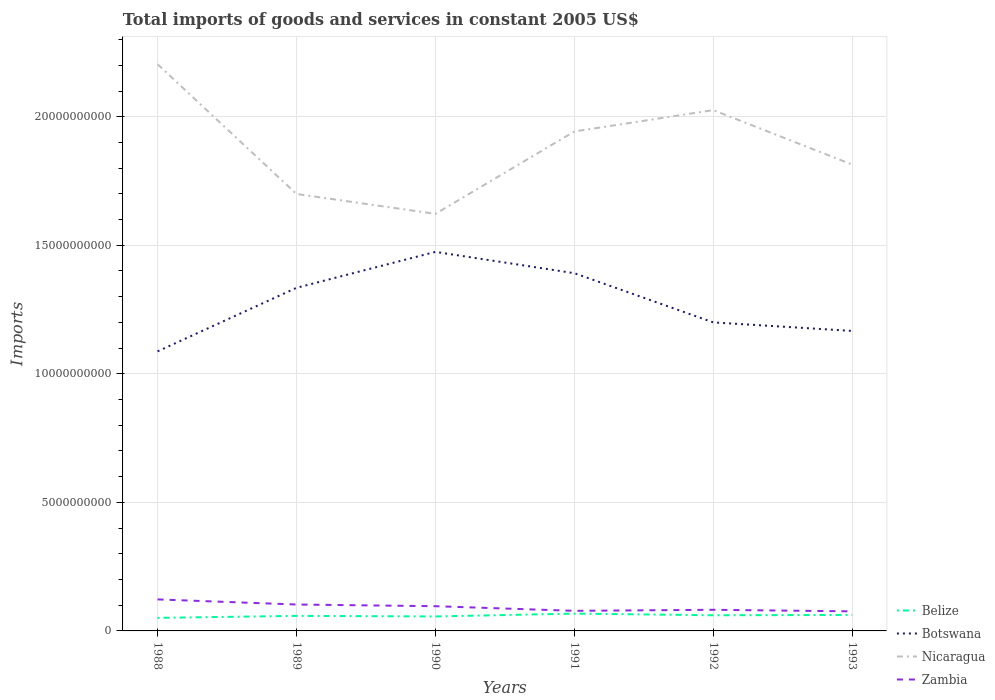How many different coloured lines are there?
Offer a terse response. 4. Is the number of lines equal to the number of legend labels?
Your answer should be compact. Yes. Across all years, what is the maximum total imports of goods and services in Zambia?
Offer a terse response. 7.61e+08. What is the total total imports of goods and services in Nicaragua in the graph?
Keep it short and to the point. 1.78e+09. What is the difference between the highest and the second highest total imports of goods and services in Botswana?
Give a very brief answer. 3.87e+09. What is the difference between two consecutive major ticks on the Y-axis?
Your answer should be very brief. 5.00e+09. Does the graph contain any zero values?
Your response must be concise. No. Does the graph contain grids?
Provide a succinct answer. Yes. Where does the legend appear in the graph?
Give a very brief answer. Bottom right. How many legend labels are there?
Provide a succinct answer. 4. What is the title of the graph?
Ensure brevity in your answer.  Total imports of goods and services in constant 2005 US$. Does "Gabon" appear as one of the legend labels in the graph?
Your response must be concise. No. What is the label or title of the X-axis?
Your answer should be compact. Years. What is the label or title of the Y-axis?
Offer a very short reply. Imports. What is the Imports in Belize in 1988?
Your answer should be compact. 5.08e+08. What is the Imports of Botswana in 1988?
Offer a very short reply. 1.09e+1. What is the Imports in Nicaragua in 1988?
Make the answer very short. 2.20e+1. What is the Imports in Zambia in 1988?
Give a very brief answer. 1.23e+09. What is the Imports in Belize in 1989?
Your answer should be compact. 5.85e+08. What is the Imports in Botswana in 1989?
Your response must be concise. 1.33e+1. What is the Imports of Nicaragua in 1989?
Ensure brevity in your answer.  1.70e+1. What is the Imports of Zambia in 1989?
Give a very brief answer. 1.03e+09. What is the Imports of Belize in 1990?
Offer a terse response. 5.63e+08. What is the Imports of Botswana in 1990?
Give a very brief answer. 1.47e+1. What is the Imports in Nicaragua in 1990?
Make the answer very short. 1.62e+1. What is the Imports of Zambia in 1990?
Your response must be concise. 9.62e+08. What is the Imports of Belize in 1991?
Keep it short and to the point. 6.74e+08. What is the Imports of Botswana in 1991?
Your answer should be very brief. 1.39e+1. What is the Imports of Nicaragua in 1991?
Your answer should be very brief. 1.94e+1. What is the Imports in Zambia in 1991?
Keep it short and to the point. 7.81e+08. What is the Imports in Belize in 1992?
Provide a succinct answer. 6.09e+08. What is the Imports of Botswana in 1992?
Give a very brief answer. 1.20e+1. What is the Imports in Nicaragua in 1992?
Ensure brevity in your answer.  2.03e+1. What is the Imports in Zambia in 1992?
Provide a succinct answer. 8.22e+08. What is the Imports in Belize in 1993?
Ensure brevity in your answer.  6.22e+08. What is the Imports of Botswana in 1993?
Offer a terse response. 1.17e+1. What is the Imports of Nicaragua in 1993?
Offer a terse response. 1.81e+1. What is the Imports in Zambia in 1993?
Offer a terse response. 7.61e+08. Across all years, what is the maximum Imports of Belize?
Offer a terse response. 6.74e+08. Across all years, what is the maximum Imports of Botswana?
Offer a terse response. 1.47e+1. Across all years, what is the maximum Imports in Nicaragua?
Give a very brief answer. 2.20e+1. Across all years, what is the maximum Imports of Zambia?
Give a very brief answer. 1.23e+09. Across all years, what is the minimum Imports of Belize?
Keep it short and to the point. 5.08e+08. Across all years, what is the minimum Imports of Botswana?
Provide a short and direct response. 1.09e+1. Across all years, what is the minimum Imports in Nicaragua?
Make the answer very short. 1.62e+1. Across all years, what is the minimum Imports of Zambia?
Give a very brief answer. 7.61e+08. What is the total Imports in Belize in the graph?
Your response must be concise. 3.56e+09. What is the total Imports in Botswana in the graph?
Keep it short and to the point. 7.65e+1. What is the total Imports in Nicaragua in the graph?
Provide a short and direct response. 1.13e+11. What is the total Imports in Zambia in the graph?
Keep it short and to the point. 5.58e+09. What is the difference between the Imports of Belize in 1988 and that in 1989?
Provide a succinct answer. -7.74e+07. What is the difference between the Imports of Botswana in 1988 and that in 1989?
Ensure brevity in your answer.  -2.47e+09. What is the difference between the Imports in Nicaragua in 1988 and that in 1989?
Make the answer very short. 5.05e+09. What is the difference between the Imports of Zambia in 1988 and that in 1989?
Give a very brief answer. 1.99e+08. What is the difference between the Imports of Belize in 1988 and that in 1990?
Provide a short and direct response. -5.47e+07. What is the difference between the Imports in Botswana in 1988 and that in 1990?
Keep it short and to the point. -3.87e+09. What is the difference between the Imports in Nicaragua in 1988 and that in 1990?
Your answer should be very brief. 5.82e+09. What is the difference between the Imports of Zambia in 1988 and that in 1990?
Give a very brief answer. 2.65e+08. What is the difference between the Imports in Belize in 1988 and that in 1991?
Give a very brief answer. -1.66e+08. What is the difference between the Imports in Botswana in 1988 and that in 1991?
Provide a succinct answer. -3.04e+09. What is the difference between the Imports in Nicaragua in 1988 and that in 1991?
Your answer should be compact. 2.61e+09. What is the difference between the Imports of Zambia in 1988 and that in 1991?
Give a very brief answer. 4.45e+08. What is the difference between the Imports of Belize in 1988 and that in 1992?
Give a very brief answer. -1.01e+08. What is the difference between the Imports of Botswana in 1988 and that in 1992?
Offer a terse response. -1.13e+09. What is the difference between the Imports of Nicaragua in 1988 and that in 1992?
Make the answer very short. 1.78e+09. What is the difference between the Imports in Zambia in 1988 and that in 1992?
Offer a very short reply. 4.04e+08. What is the difference between the Imports of Belize in 1988 and that in 1993?
Keep it short and to the point. -1.14e+08. What is the difference between the Imports of Botswana in 1988 and that in 1993?
Make the answer very short. -7.95e+08. What is the difference between the Imports of Nicaragua in 1988 and that in 1993?
Make the answer very short. 3.90e+09. What is the difference between the Imports of Zambia in 1988 and that in 1993?
Provide a short and direct response. 4.65e+08. What is the difference between the Imports in Belize in 1989 and that in 1990?
Your answer should be compact. 2.27e+07. What is the difference between the Imports of Botswana in 1989 and that in 1990?
Keep it short and to the point. -1.40e+09. What is the difference between the Imports of Nicaragua in 1989 and that in 1990?
Offer a terse response. 7.73e+08. What is the difference between the Imports of Zambia in 1989 and that in 1990?
Keep it short and to the point. 6.56e+07. What is the difference between the Imports of Belize in 1989 and that in 1991?
Your answer should be very brief. -8.83e+07. What is the difference between the Imports in Botswana in 1989 and that in 1991?
Your answer should be compact. -5.68e+08. What is the difference between the Imports in Nicaragua in 1989 and that in 1991?
Ensure brevity in your answer.  -2.43e+09. What is the difference between the Imports of Zambia in 1989 and that in 1991?
Keep it short and to the point. 2.46e+08. What is the difference between the Imports of Belize in 1989 and that in 1992?
Make the answer very short. -2.39e+07. What is the difference between the Imports in Botswana in 1989 and that in 1992?
Provide a succinct answer. 1.35e+09. What is the difference between the Imports of Nicaragua in 1989 and that in 1992?
Offer a very short reply. -3.26e+09. What is the difference between the Imports of Zambia in 1989 and that in 1992?
Give a very brief answer. 2.05e+08. What is the difference between the Imports in Belize in 1989 and that in 1993?
Provide a succinct answer. -3.70e+07. What is the difference between the Imports in Botswana in 1989 and that in 1993?
Give a very brief answer. 1.68e+09. What is the difference between the Imports of Nicaragua in 1989 and that in 1993?
Provide a succinct answer. -1.14e+09. What is the difference between the Imports in Zambia in 1989 and that in 1993?
Provide a succinct answer. 2.66e+08. What is the difference between the Imports in Belize in 1990 and that in 1991?
Give a very brief answer. -1.11e+08. What is the difference between the Imports of Botswana in 1990 and that in 1991?
Ensure brevity in your answer.  8.29e+08. What is the difference between the Imports of Nicaragua in 1990 and that in 1991?
Provide a short and direct response. -3.20e+09. What is the difference between the Imports in Zambia in 1990 and that in 1991?
Keep it short and to the point. 1.80e+08. What is the difference between the Imports of Belize in 1990 and that in 1992?
Provide a succinct answer. -4.67e+07. What is the difference between the Imports of Botswana in 1990 and that in 1992?
Offer a very short reply. 2.74e+09. What is the difference between the Imports in Nicaragua in 1990 and that in 1992?
Your answer should be very brief. -4.04e+09. What is the difference between the Imports of Zambia in 1990 and that in 1992?
Keep it short and to the point. 1.40e+08. What is the difference between the Imports of Belize in 1990 and that in 1993?
Provide a short and direct response. -5.97e+07. What is the difference between the Imports in Botswana in 1990 and that in 1993?
Keep it short and to the point. 3.07e+09. What is the difference between the Imports of Nicaragua in 1990 and that in 1993?
Keep it short and to the point. -1.92e+09. What is the difference between the Imports in Zambia in 1990 and that in 1993?
Your answer should be compact. 2.00e+08. What is the difference between the Imports of Belize in 1991 and that in 1992?
Ensure brevity in your answer.  6.43e+07. What is the difference between the Imports of Botswana in 1991 and that in 1992?
Offer a terse response. 1.91e+09. What is the difference between the Imports of Nicaragua in 1991 and that in 1992?
Make the answer very short. -8.32e+08. What is the difference between the Imports of Zambia in 1991 and that in 1992?
Provide a succinct answer. -4.08e+07. What is the difference between the Imports in Belize in 1991 and that in 1993?
Your answer should be compact. 5.13e+07. What is the difference between the Imports in Botswana in 1991 and that in 1993?
Provide a succinct answer. 2.25e+09. What is the difference between the Imports of Nicaragua in 1991 and that in 1993?
Ensure brevity in your answer.  1.29e+09. What is the difference between the Imports of Zambia in 1991 and that in 1993?
Offer a terse response. 2.00e+07. What is the difference between the Imports of Belize in 1992 and that in 1993?
Provide a short and direct response. -1.30e+07. What is the difference between the Imports in Botswana in 1992 and that in 1993?
Make the answer very short. 3.32e+08. What is the difference between the Imports of Nicaragua in 1992 and that in 1993?
Keep it short and to the point. 2.12e+09. What is the difference between the Imports in Zambia in 1992 and that in 1993?
Give a very brief answer. 6.08e+07. What is the difference between the Imports of Belize in 1988 and the Imports of Botswana in 1989?
Make the answer very short. -1.28e+1. What is the difference between the Imports in Belize in 1988 and the Imports in Nicaragua in 1989?
Offer a very short reply. -1.65e+1. What is the difference between the Imports in Belize in 1988 and the Imports in Zambia in 1989?
Offer a terse response. -5.19e+08. What is the difference between the Imports in Botswana in 1988 and the Imports in Nicaragua in 1989?
Your answer should be very brief. -6.12e+09. What is the difference between the Imports of Botswana in 1988 and the Imports of Zambia in 1989?
Provide a short and direct response. 9.85e+09. What is the difference between the Imports in Nicaragua in 1988 and the Imports in Zambia in 1989?
Offer a terse response. 2.10e+1. What is the difference between the Imports in Belize in 1988 and the Imports in Botswana in 1990?
Provide a succinct answer. -1.42e+1. What is the difference between the Imports of Belize in 1988 and the Imports of Nicaragua in 1990?
Offer a very short reply. -1.57e+1. What is the difference between the Imports of Belize in 1988 and the Imports of Zambia in 1990?
Make the answer very short. -4.54e+08. What is the difference between the Imports of Botswana in 1988 and the Imports of Nicaragua in 1990?
Provide a short and direct response. -5.35e+09. What is the difference between the Imports of Botswana in 1988 and the Imports of Zambia in 1990?
Give a very brief answer. 9.91e+09. What is the difference between the Imports in Nicaragua in 1988 and the Imports in Zambia in 1990?
Your answer should be compact. 2.11e+1. What is the difference between the Imports of Belize in 1988 and the Imports of Botswana in 1991?
Provide a short and direct response. -1.34e+1. What is the difference between the Imports of Belize in 1988 and the Imports of Nicaragua in 1991?
Provide a succinct answer. -1.89e+1. What is the difference between the Imports of Belize in 1988 and the Imports of Zambia in 1991?
Your answer should be very brief. -2.73e+08. What is the difference between the Imports of Botswana in 1988 and the Imports of Nicaragua in 1991?
Provide a short and direct response. -8.55e+09. What is the difference between the Imports of Botswana in 1988 and the Imports of Zambia in 1991?
Your answer should be very brief. 1.01e+1. What is the difference between the Imports of Nicaragua in 1988 and the Imports of Zambia in 1991?
Provide a succinct answer. 2.13e+1. What is the difference between the Imports of Belize in 1988 and the Imports of Botswana in 1992?
Offer a very short reply. -1.15e+1. What is the difference between the Imports in Belize in 1988 and the Imports in Nicaragua in 1992?
Ensure brevity in your answer.  -1.98e+1. What is the difference between the Imports in Belize in 1988 and the Imports in Zambia in 1992?
Offer a very short reply. -3.14e+08. What is the difference between the Imports in Botswana in 1988 and the Imports in Nicaragua in 1992?
Your answer should be very brief. -9.38e+09. What is the difference between the Imports in Botswana in 1988 and the Imports in Zambia in 1992?
Offer a very short reply. 1.01e+1. What is the difference between the Imports of Nicaragua in 1988 and the Imports of Zambia in 1992?
Offer a very short reply. 2.12e+1. What is the difference between the Imports of Belize in 1988 and the Imports of Botswana in 1993?
Offer a terse response. -1.12e+1. What is the difference between the Imports of Belize in 1988 and the Imports of Nicaragua in 1993?
Provide a succinct answer. -1.76e+1. What is the difference between the Imports of Belize in 1988 and the Imports of Zambia in 1993?
Make the answer very short. -2.53e+08. What is the difference between the Imports in Botswana in 1988 and the Imports in Nicaragua in 1993?
Your response must be concise. -7.27e+09. What is the difference between the Imports in Botswana in 1988 and the Imports in Zambia in 1993?
Offer a terse response. 1.01e+1. What is the difference between the Imports in Nicaragua in 1988 and the Imports in Zambia in 1993?
Your response must be concise. 2.13e+1. What is the difference between the Imports of Belize in 1989 and the Imports of Botswana in 1990?
Give a very brief answer. -1.42e+1. What is the difference between the Imports of Belize in 1989 and the Imports of Nicaragua in 1990?
Provide a short and direct response. -1.56e+1. What is the difference between the Imports of Belize in 1989 and the Imports of Zambia in 1990?
Offer a terse response. -3.76e+08. What is the difference between the Imports of Botswana in 1989 and the Imports of Nicaragua in 1990?
Your answer should be compact. -2.88e+09. What is the difference between the Imports of Botswana in 1989 and the Imports of Zambia in 1990?
Offer a terse response. 1.24e+1. What is the difference between the Imports of Nicaragua in 1989 and the Imports of Zambia in 1990?
Provide a succinct answer. 1.60e+1. What is the difference between the Imports of Belize in 1989 and the Imports of Botswana in 1991?
Provide a short and direct response. -1.33e+1. What is the difference between the Imports in Belize in 1989 and the Imports in Nicaragua in 1991?
Offer a terse response. -1.88e+1. What is the difference between the Imports in Belize in 1989 and the Imports in Zambia in 1991?
Offer a terse response. -1.96e+08. What is the difference between the Imports of Botswana in 1989 and the Imports of Nicaragua in 1991?
Keep it short and to the point. -6.08e+09. What is the difference between the Imports in Botswana in 1989 and the Imports in Zambia in 1991?
Your response must be concise. 1.26e+1. What is the difference between the Imports of Nicaragua in 1989 and the Imports of Zambia in 1991?
Offer a terse response. 1.62e+1. What is the difference between the Imports of Belize in 1989 and the Imports of Botswana in 1992?
Your answer should be very brief. -1.14e+1. What is the difference between the Imports in Belize in 1989 and the Imports in Nicaragua in 1992?
Give a very brief answer. -1.97e+1. What is the difference between the Imports in Belize in 1989 and the Imports in Zambia in 1992?
Your answer should be very brief. -2.37e+08. What is the difference between the Imports of Botswana in 1989 and the Imports of Nicaragua in 1992?
Your response must be concise. -6.91e+09. What is the difference between the Imports in Botswana in 1989 and the Imports in Zambia in 1992?
Make the answer very short. 1.25e+1. What is the difference between the Imports in Nicaragua in 1989 and the Imports in Zambia in 1992?
Your answer should be very brief. 1.62e+1. What is the difference between the Imports of Belize in 1989 and the Imports of Botswana in 1993?
Make the answer very short. -1.11e+1. What is the difference between the Imports in Belize in 1989 and the Imports in Nicaragua in 1993?
Your response must be concise. -1.76e+1. What is the difference between the Imports of Belize in 1989 and the Imports of Zambia in 1993?
Your response must be concise. -1.76e+08. What is the difference between the Imports of Botswana in 1989 and the Imports of Nicaragua in 1993?
Your answer should be compact. -4.79e+09. What is the difference between the Imports of Botswana in 1989 and the Imports of Zambia in 1993?
Offer a very short reply. 1.26e+1. What is the difference between the Imports of Nicaragua in 1989 and the Imports of Zambia in 1993?
Ensure brevity in your answer.  1.62e+1. What is the difference between the Imports in Belize in 1990 and the Imports in Botswana in 1991?
Keep it short and to the point. -1.34e+1. What is the difference between the Imports in Belize in 1990 and the Imports in Nicaragua in 1991?
Make the answer very short. -1.89e+1. What is the difference between the Imports of Belize in 1990 and the Imports of Zambia in 1991?
Offer a terse response. -2.19e+08. What is the difference between the Imports in Botswana in 1990 and the Imports in Nicaragua in 1991?
Your response must be concise. -4.68e+09. What is the difference between the Imports in Botswana in 1990 and the Imports in Zambia in 1991?
Ensure brevity in your answer.  1.40e+1. What is the difference between the Imports of Nicaragua in 1990 and the Imports of Zambia in 1991?
Provide a short and direct response. 1.54e+1. What is the difference between the Imports of Belize in 1990 and the Imports of Botswana in 1992?
Keep it short and to the point. -1.14e+1. What is the difference between the Imports of Belize in 1990 and the Imports of Nicaragua in 1992?
Provide a short and direct response. -1.97e+1. What is the difference between the Imports of Belize in 1990 and the Imports of Zambia in 1992?
Your response must be concise. -2.59e+08. What is the difference between the Imports in Botswana in 1990 and the Imports in Nicaragua in 1992?
Your answer should be compact. -5.51e+09. What is the difference between the Imports of Botswana in 1990 and the Imports of Zambia in 1992?
Your response must be concise. 1.39e+1. What is the difference between the Imports in Nicaragua in 1990 and the Imports in Zambia in 1992?
Give a very brief answer. 1.54e+1. What is the difference between the Imports in Belize in 1990 and the Imports in Botswana in 1993?
Keep it short and to the point. -1.11e+1. What is the difference between the Imports of Belize in 1990 and the Imports of Nicaragua in 1993?
Offer a terse response. -1.76e+1. What is the difference between the Imports of Belize in 1990 and the Imports of Zambia in 1993?
Ensure brevity in your answer.  -1.99e+08. What is the difference between the Imports in Botswana in 1990 and the Imports in Nicaragua in 1993?
Make the answer very short. -3.40e+09. What is the difference between the Imports of Botswana in 1990 and the Imports of Zambia in 1993?
Your answer should be very brief. 1.40e+1. What is the difference between the Imports in Nicaragua in 1990 and the Imports in Zambia in 1993?
Offer a terse response. 1.55e+1. What is the difference between the Imports of Belize in 1991 and the Imports of Botswana in 1992?
Your response must be concise. -1.13e+1. What is the difference between the Imports of Belize in 1991 and the Imports of Nicaragua in 1992?
Provide a succinct answer. -1.96e+1. What is the difference between the Imports in Belize in 1991 and the Imports in Zambia in 1992?
Provide a short and direct response. -1.48e+08. What is the difference between the Imports of Botswana in 1991 and the Imports of Nicaragua in 1992?
Offer a very short reply. -6.34e+09. What is the difference between the Imports of Botswana in 1991 and the Imports of Zambia in 1992?
Offer a very short reply. 1.31e+1. What is the difference between the Imports in Nicaragua in 1991 and the Imports in Zambia in 1992?
Offer a very short reply. 1.86e+1. What is the difference between the Imports in Belize in 1991 and the Imports in Botswana in 1993?
Offer a terse response. -1.10e+1. What is the difference between the Imports in Belize in 1991 and the Imports in Nicaragua in 1993?
Keep it short and to the point. -1.75e+1. What is the difference between the Imports in Belize in 1991 and the Imports in Zambia in 1993?
Your response must be concise. -8.76e+07. What is the difference between the Imports of Botswana in 1991 and the Imports of Nicaragua in 1993?
Offer a terse response. -4.23e+09. What is the difference between the Imports in Botswana in 1991 and the Imports in Zambia in 1993?
Keep it short and to the point. 1.32e+1. What is the difference between the Imports of Nicaragua in 1991 and the Imports of Zambia in 1993?
Your response must be concise. 1.87e+1. What is the difference between the Imports in Belize in 1992 and the Imports in Botswana in 1993?
Make the answer very short. -1.11e+1. What is the difference between the Imports of Belize in 1992 and the Imports of Nicaragua in 1993?
Give a very brief answer. -1.75e+1. What is the difference between the Imports in Belize in 1992 and the Imports in Zambia in 1993?
Ensure brevity in your answer.  -1.52e+08. What is the difference between the Imports of Botswana in 1992 and the Imports of Nicaragua in 1993?
Provide a succinct answer. -6.14e+09. What is the difference between the Imports of Botswana in 1992 and the Imports of Zambia in 1993?
Give a very brief answer. 1.12e+1. What is the difference between the Imports in Nicaragua in 1992 and the Imports in Zambia in 1993?
Keep it short and to the point. 1.95e+1. What is the average Imports of Belize per year?
Give a very brief answer. 5.93e+08. What is the average Imports in Botswana per year?
Provide a short and direct response. 1.28e+1. What is the average Imports in Nicaragua per year?
Keep it short and to the point. 1.88e+1. What is the average Imports in Zambia per year?
Offer a terse response. 9.30e+08. In the year 1988, what is the difference between the Imports of Belize and Imports of Botswana?
Offer a terse response. -1.04e+1. In the year 1988, what is the difference between the Imports in Belize and Imports in Nicaragua?
Give a very brief answer. -2.15e+1. In the year 1988, what is the difference between the Imports of Belize and Imports of Zambia?
Keep it short and to the point. -7.18e+08. In the year 1988, what is the difference between the Imports in Botswana and Imports in Nicaragua?
Provide a short and direct response. -1.12e+1. In the year 1988, what is the difference between the Imports of Botswana and Imports of Zambia?
Keep it short and to the point. 9.65e+09. In the year 1988, what is the difference between the Imports of Nicaragua and Imports of Zambia?
Offer a very short reply. 2.08e+1. In the year 1989, what is the difference between the Imports of Belize and Imports of Botswana?
Offer a terse response. -1.28e+1. In the year 1989, what is the difference between the Imports in Belize and Imports in Nicaragua?
Give a very brief answer. -1.64e+1. In the year 1989, what is the difference between the Imports of Belize and Imports of Zambia?
Ensure brevity in your answer.  -4.42e+08. In the year 1989, what is the difference between the Imports of Botswana and Imports of Nicaragua?
Your answer should be very brief. -3.65e+09. In the year 1989, what is the difference between the Imports of Botswana and Imports of Zambia?
Make the answer very short. 1.23e+1. In the year 1989, what is the difference between the Imports in Nicaragua and Imports in Zambia?
Your answer should be very brief. 1.60e+1. In the year 1990, what is the difference between the Imports in Belize and Imports in Botswana?
Your answer should be compact. -1.42e+1. In the year 1990, what is the difference between the Imports in Belize and Imports in Nicaragua?
Offer a very short reply. -1.57e+1. In the year 1990, what is the difference between the Imports of Belize and Imports of Zambia?
Make the answer very short. -3.99e+08. In the year 1990, what is the difference between the Imports in Botswana and Imports in Nicaragua?
Give a very brief answer. -1.48e+09. In the year 1990, what is the difference between the Imports in Botswana and Imports in Zambia?
Offer a terse response. 1.38e+1. In the year 1990, what is the difference between the Imports in Nicaragua and Imports in Zambia?
Provide a succinct answer. 1.53e+1. In the year 1991, what is the difference between the Imports of Belize and Imports of Botswana?
Provide a succinct answer. -1.32e+1. In the year 1991, what is the difference between the Imports of Belize and Imports of Nicaragua?
Provide a short and direct response. -1.88e+1. In the year 1991, what is the difference between the Imports in Belize and Imports in Zambia?
Provide a succinct answer. -1.08e+08. In the year 1991, what is the difference between the Imports of Botswana and Imports of Nicaragua?
Your answer should be very brief. -5.51e+09. In the year 1991, what is the difference between the Imports in Botswana and Imports in Zambia?
Offer a terse response. 1.31e+1. In the year 1991, what is the difference between the Imports of Nicaragua and Imports of Zambia?
Your response must be concise. 1.86e+1. In the year 1992, what is the difference between the Imports in Belize and Imports in Botswana?
Offer a very short reply. -1.14e+1. In the year 1992, what is the difference between the Imports of Belize and Imports of Nicaragua?
Keep it short and to the point. -1.96e+1. In the year 1992, what is the difference between the Imports of Belize and Imports of Zambia?
Keep it short and to the point. -2.13e+08. In the year 1992, what is the difference between the Imports of Botswana and Imports of Nicaragua?
Keep it short and to the point. -8.26e+09. In the year 1992, what is the difference between the Imports of Botswana and Imports of Zambia?
Ensure brevity in your answer.  1.12e+1. In the year 1992, what is the difference between the Imports of Nicaragua and Imports of Zambia?
Offer a very short reply. 1.94e+1. In the year 1993, what is the difference between the Imports in Belize and Imports in Botswana?
Offer a very short reply. -1.10e+1. In the year 1993, what is the difference between the Imports of Belize and Imports of Nicaragua?
Offer a very short reply. -1.75e+1. In the year 1993, what is the difference between the Imports of Belize and Imports of Zambia?
Offer a very short reply. -1.39e+08. In the year 1993, what is the difference between the Imports of Botswana and Imports of Nicaragua?
Offer a very short reply. -6.47e+09. In the year 1993, what is the difference between the Imports in Botswana and Imports in Zambia?
Offer a very short reply. 1.09e+1. In the year 1993, what is the difference between the Imports in Nicaragua and Imports in Zambia?
Provide a succinct answer. 1.74e+1. What is the ratio of the Imports in Belize in 1988 to that in 1989?
Keep it short and to the point. 0.87. What is the ratio of the Imports of Botswana in 1988 to that in 1989?
Your response must be concise. 0.81. What is the ratio of the Imports in Nicaragua in 1988 to that in 1989?
Ensure brevity in your answer.  1.3. What is the ratio of the Imports in Zambia in 1988 to that in 1989?
Your answer should be compact. 1.19. What is the ratio of the Imports in Belize in 1988 to that in 1990?
Provide a short and direct response. 0.9. What is the ratio of the Imports of Botswana in 1988 to that in 1990?
Give a very brief answer. 0.74. What is the ratio of the Imports of Nicaragua in 1988 to that in 1990?
Provide a short and direct response. 1.36. What is the ratio of the Imports in Zambia in 1988 to that in 1990?
Ensure brevity in your answer.  1.28. What is the ratio of the Imports in Belize in 1988 to that in 1991?
Your response must be concise. 0.75. What is the ratio of the Imports in Botswana in 1988 to that in 1991?
Provide a short and direct response. 0.78. What is the ratio of the Imports of Nicaragua in 1988 to that in 1991?
Offer a terse response. 1.13. What is the ratio of the Imports in Zambia in 1988 to that in 1991?
Your answer should be compact. 1.57. What is the ratio of the Imports in Belize in 1988 to that in 1992?
Offer a very short reply. 0.83. What is the ratio of the Imports in Botswana in 1988 to that in 1992?
Provide a short and direct response. 0.91. What is the ratio of the Imports of Nicaragua in 1988 to that in 1992?
Keep it short and to the point. 1.09. What is the ratio of the Imports of Zambia in 1988 to that in 1992?
Your response must be concise. 1.49. What is the ratio of the Imports in Belize in 1988 to that in 1993?
Give a very brief answer. 0.82. What is the ratio of the Imports of Botswana in 1988 to that in 1993?
Keep it short and to the point. 0.93. What is the ratio of the Imports in Nicaragua in 1988 to that in 1993?
Your answer should be very brief. 1.22. What is the ratio of the Imports in Zambia in 1988 to that in 1993?
Keep it short and to the point. 1.61. What is the ratio of the Imports in Belize in 1989 to that in 1990?
Offer a very short reply. 1.04. What is the ratio of the Imports in Botswana in 1989 to that in 1990?
Your answer should be compact. 0.91. What is the ratio of the Imports in Nicaragua in 1989 to that in 1990?
Your answer should be very brief. 1.05. What is the ratio of the Imports of Zambia in 1989 to that in 1990?
Keep it short and to the point. 1.07. What is the ratio of the Imports of Belize in 1989 to that in 1991?
Keep it short and to the point. 0.87. What is the ratio of the Imports in Botswana in 1989 to that in 1991?
Ensure brevity in your answer.  0.96. What is the ratio of the Imports in Nicaragua in 1989 to that in 1991?
Give a very brief answer. 0.87. What is the ratio of the Imports in Zambia in 1989 to that in 1991?
Offer a terse response. 1.31. What is the ratio of the Imports of Belize in 1989 to that in 1992?
Offer a terse response. 0.96. What is the ratio of the Imports in Botswana in 1989 to that in 1992?
Your response must be concise. 1.11. What is the ratio of the Imports in Nicaragua in 1989 to that in 1992?
Your answer should be very brief. 0.84. What is the ratio of the Imports in Zambia in 1989 to that in 1992?
Give a very brief answer. 1.25. What is the ratio of the Imports of Belize in 1989 to that in 1993?
Your response must be concise. 0.94. What is the ratio of the Imports in Botswana in 1989 to that in 1993?
Offer a very short reply. 1.14. What is the ratio of the Imports in Nicaragua in 1989 to that in 1993?
Your answer should be compact. 0.94. What is the ratio of the Imports of Zambia in 1989 to that in 1993?
Offer a very short reply. 1.35. What is the ratio of the Imports in Belize in 1990 to that in 1991?
Your answer should be very brief. 0.84. What is the ratio of the Imports in Botswana in 1990 to that in 1991?
Provide a succinct answer. 1.06. What is the ratio of the Imports of Nicaragua in 1990 to that in 1991?
Your response must be concise. 0.84. What is the ratio of the Imports of Zambia in 1990 to that in 1991?
Give a very brief answer. 1.23. What is the ratio of the Imports in Belize in 1990 to that in 1992?
Give a very brief answer. 0.92. What is the ratio of the Imports in Botswana in 1990 to that in 1992?
Provide a short and direct response. 1.23. What is the ratio of the Imports in Nicaragua in 1990 to that in 1992?
Make the answer very short. 0.8. What is the ratio of the Imports of Zambia in 1990 to that in 1992?
Your answer should be compact. 1.17. What is the ratio of the Imports in Belize in 1990 to that in 1993?
Give a very brief answer. 0.9. What is the ratio of the Imports in Botswana in 1990 to that in 1993?
Your answer should be compact. 1.26. What is the ratio of the Imports of Nicaragua in 1990 to that in 1993?
Ensure brevity in your answer.  0.89. What is the ratio of the Imports of Zambia in 1990 to that in 1993?
Provide a short and direct response. 1.26. What is the ratio of the Imports of Belize in 1991 to that in 1992?
Offer a terse response. 1.11. What is the ratio of the Imports of Botswana in 1991 to that in 1992?
Your response must be concise. 1.16. What is the ratio of the Imports of Zambia in 1991 to that in 1992?
Offer a very short reply. 0.95. What is the ratio of the Imports in Belize in 1991 to that in 1993?
Offer a very short reply. 1.08. What is the ratio of the Imports in Botswana in 1991 to that in 1993?
Make the answer very short. 1.19. What is the ratio of the Imports of Nicaragua in 1991 to that in 1993?
Keep it short and to the point. 1.07. What is the ratio of the Imports of Zambia in 1991 to that in 1993?
Provide a short and direct response. 1.03. What is the ratio of the Imports in Belize in 1992 to that in 1993?
Your answer should be very brief. 0.98. What is the ratio of the Imports in Botswana in 1992 to that in 1993?
Make the answer very short. 1.03. What is the ratio of the Imports of Nicaragua in 1992 to that in 1993?
Provide a short and direct response. 1.12. What is the ratio of the Imports in Zambia in 1992 to that in 1993?
Your answer should be very brief. 1.08. What is the difference between the highest and the second highest Imports of Belize?
Ensure brevity in your answer.  5.13e+07. What is the difference between the highest and the second highest Imports in Botswana?
Keep it short and to the point. 8.29e+08. What is the difference between the highest and the second highest Imports of Nicaragua?
Provide a succinct answer. 1.78e+09. What is the difference between the highest and the second highest Imports of Zambia?
Your answer should be compact. 1.99e+08. What is the difference between the highest and the lowest Imports of Belize?
Make the answer very short. 1.66e+08. What is the difference between the highest and the lowest Imports in Botswana?
Ensure brevity in your answer.  3.87e+09. What is the difference between the highest and the lowest Imports in Nicaragua?
Provide a succinct answer. 5.82e+09. What is the difference between the highest and the lowest Imports of Zambia?
Your answer should be compact. 4.65e+08. 